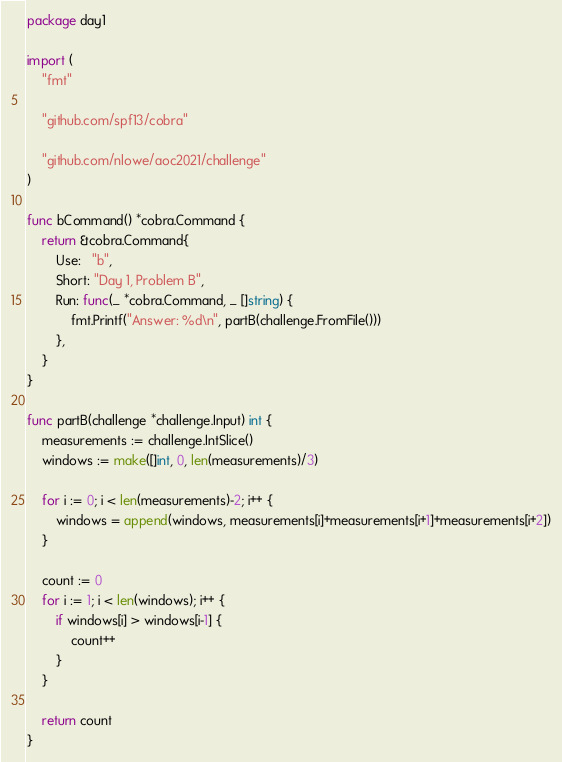Convert code to text. <code><loc_0><loc_0><loc_500><loc_500><_Go_>package day1

import (
	"fmt"

	"github.com/spf13/cobra"

	"github.com/nlowe/aoc2021/challenge"
)

func bCommand() *cobra.Command {
	return &cobra.Command{
		Use:   "b",
		Short: "Day 1, Problem B",
		Run: func(_ *cobra.Command, _ []string) {
			fmt.Printf("Answer: %d\n", partB(challenge.FromFile()))
		},
	}
}

func partB(challenge *challenge.Input) int {
	measurements := challenge.IntSlice()
	windows := make([]int, 0, len(measurements)/3)

	for i := 0; i < len(measurements)-2; i++ {
		windows = append(windows, measurements[i]+measurements[i+1]+measurements[i+2])
	}

	count := 0
	for i := 1; i < len(windows); i++ {
		if windows[i] > windows[i-1] {
			count++
		}
	}

	return count
}
</code> 